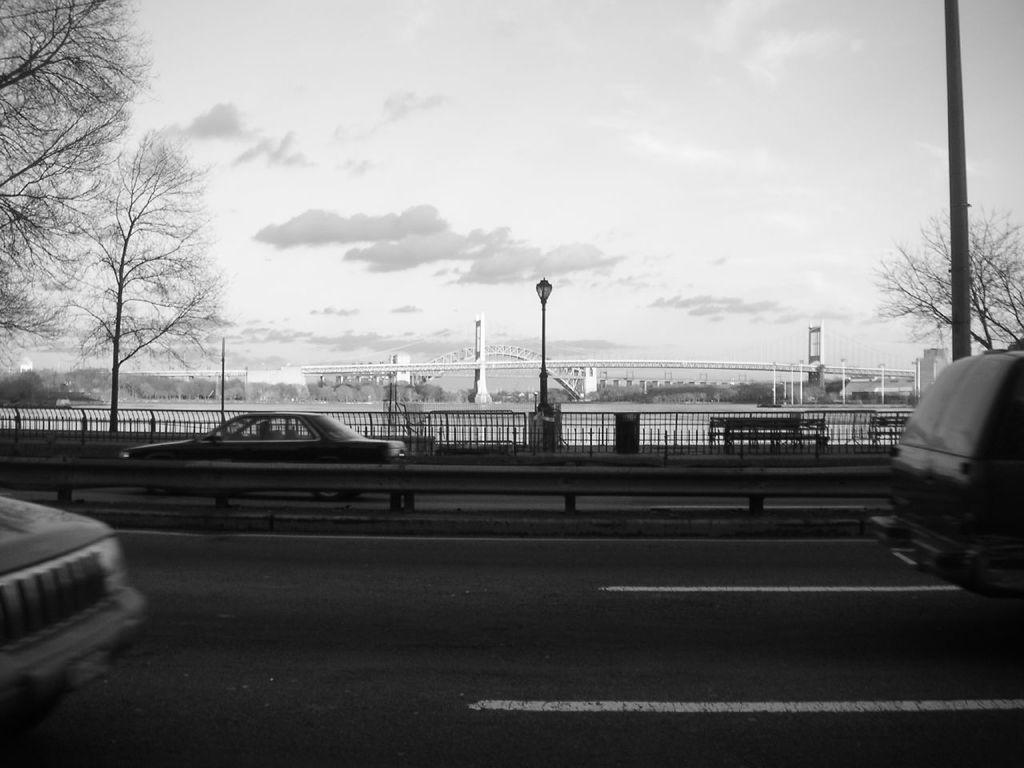What can be seen on the road in the image? There are vehicles on the road in the image. What type of natural elements are visible in the background of the image? There are trees in the background of the image. What architectural features can be seen in the background of the image? There is a fence, street lights, a bridge, and buildings in the background of the image. What part of the natural environment is visible in the background of the image? The sky is visible in the background of the image. What is the color scheme of the image? The image is black and white in color. What type of trousers are the vehicles wearing in the image? Vehicles do not wear trousers; they are inanimate objects. Can you see any pets in the image? There are no pets visible in the image. What color is the eye of the bridge in the image? Bridges do not have eyes, as they are inanimate objects. 